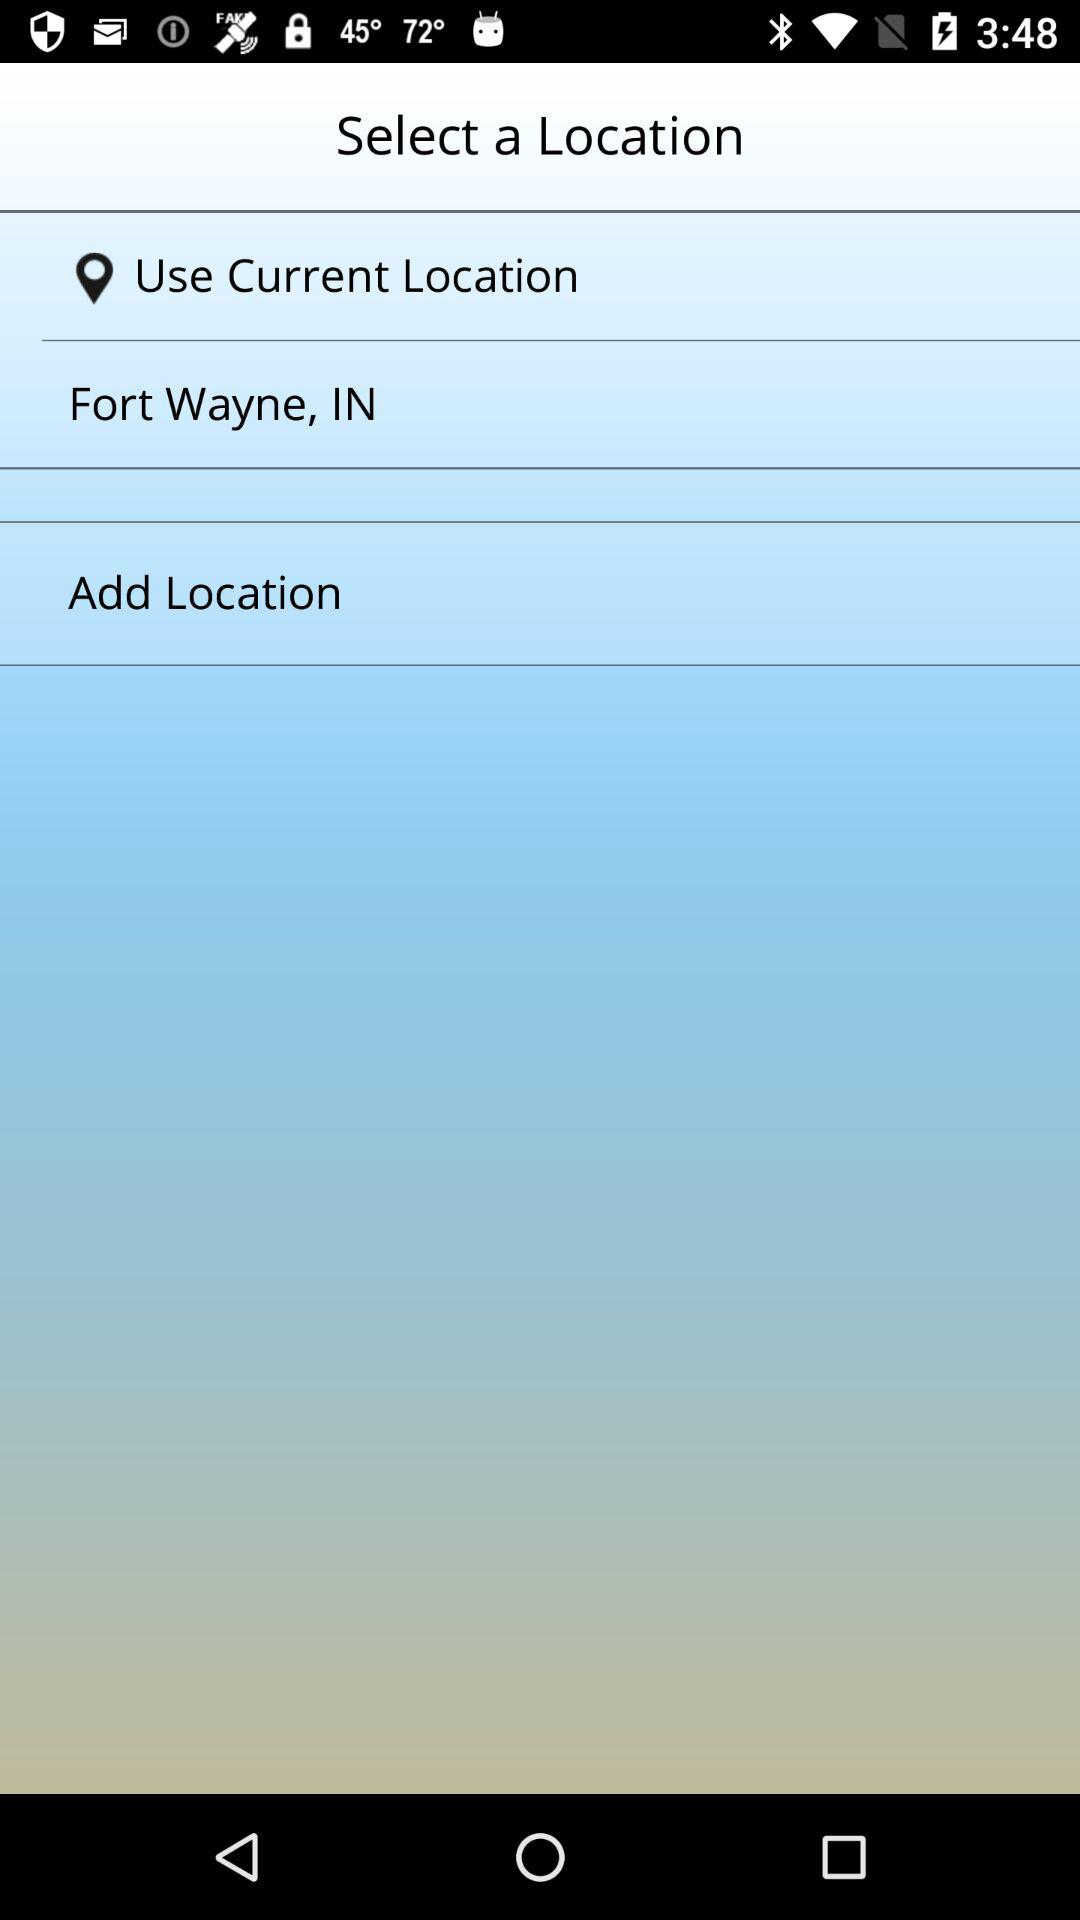What is the mentioned location? The mentioned location is Fort Wayne, IN. 